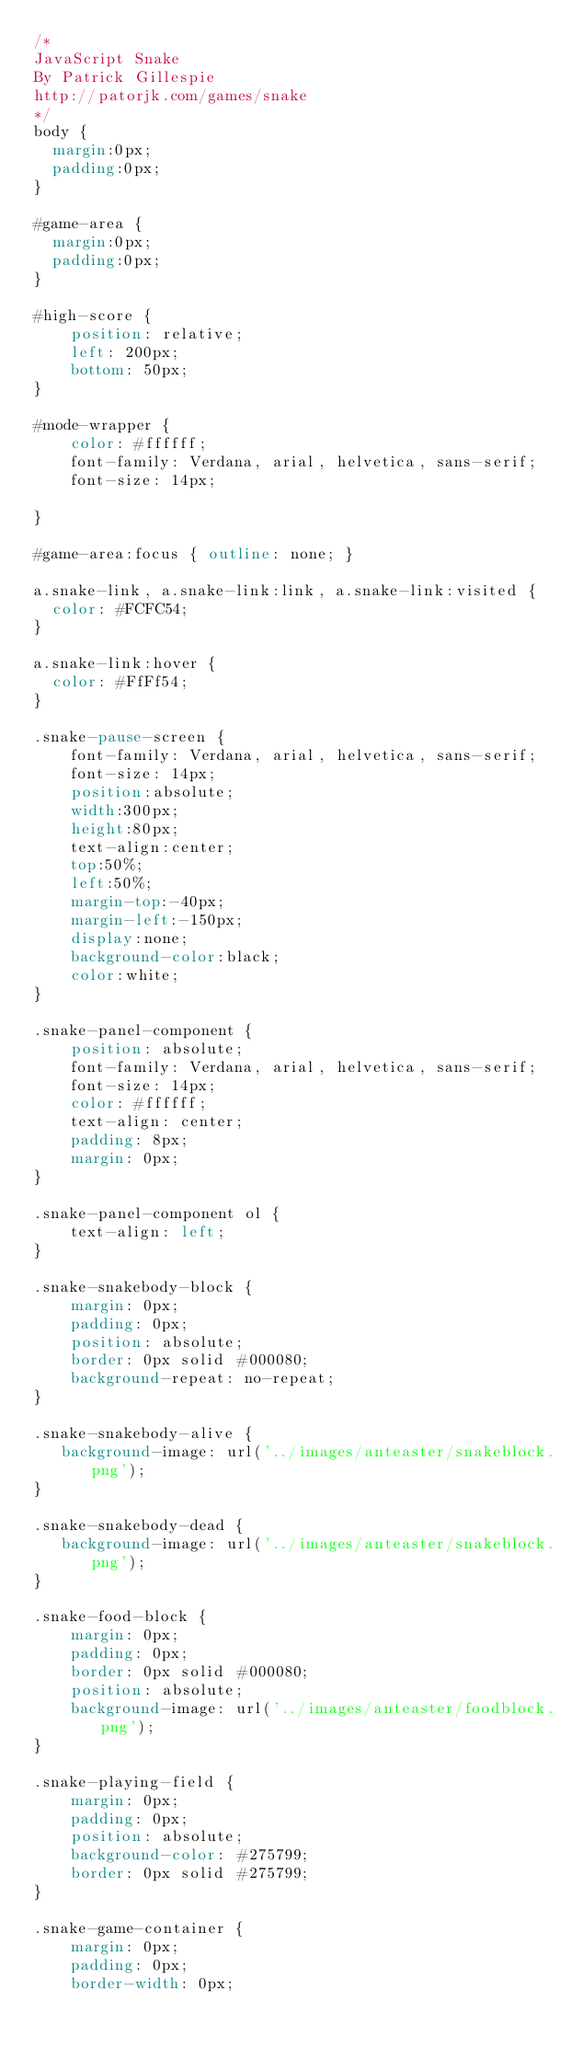Convert code to text. <code><loc_0><loc_0><loc_500><loc_500><_CSS_>/*
JavaScript Snake
By Patrick Gillespie
http://patorjk.com/games/snake
*/
body {
	margin:0px;
	padding:0px;
}

#game-area {
	margin:0px;
	padding:0px;
}

#high-score {
    position: relative;
    left: 200px;
    bottom: 50px;
}

#mode-wrapper {
    color: #ffffff;
    font-family: Verdana, arial, helvetica, sans-serif; 
    font-size: 14px;
    
}

#game-area:focus { outline: none; }

a.snake-link, a.snake-link:link, a.snake-link:visited {
  color: #FCFC54; 
}

a.snake-link:hover {
  color: #FfFf54; 
}

.snake-pause-screen {
    font-family: Verdana, arial, helvetica, sans-serif; 
    font-size: 14px;
    position:absolute;
    width:300px;
    height:80px;
    text-align:center;
    top:50%;
    left:50%;
    margin-top:-40px;
    margin-left:-150px;
    display:none;
    background-color:black;
    color:white;
}

.snake-panel-component {
    position: absolute;
    font-family: Verdana, arial, helvetica, sans-serif; 
    font-size: 14px;
    color: #ffffff;
    text-align: center;
    padding: 8px;
    margin: 0px;
}

.snake-panel-component ol {
    text-align: left;
}

.snake-snakebody-block {
    margin: 0px;
    padding: 0px;
    position: absolute;
    border: 0px solid #000080;
    background-repeat: no-repeat;
}

.snake-snakebody-alive {
   background-image: url('../images/anteaster/snakeblock.png');
}

.snake-snakebody-dead {
   background-image: url('../images/anteaster/snakeblock.png');
}

.snake-food-block {
    margin: 0px;
    padding: 0px;
    border: 0px solid #000080;
    position: absolute;
    background-image: url('../images/anteaster/foodblock.png');
}

.snake-playing-field {
    margin: 0px;
    padding: 0px;
    position: absolute;
    background-color: #275799;
    border: 0px solid #275799;
}

.snake-game-container {
    margin: 0px;
    padding: 0px;
    border-width: 0px;</code> 